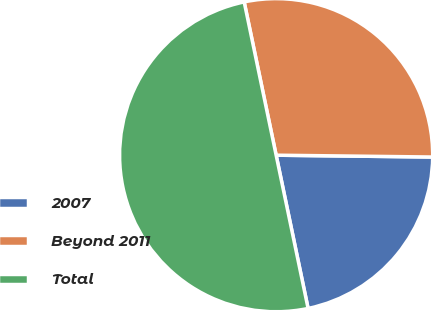Convert chart to OTSL. <chart><loc_0><loc_0><loc_500><loc_500><pie_chart><fcel>2007<fcel>Beyond 2011<fcel>Total<nl><fcel>21.54%<fcel>28.46%<fcel>50.0%<nl></chart> 